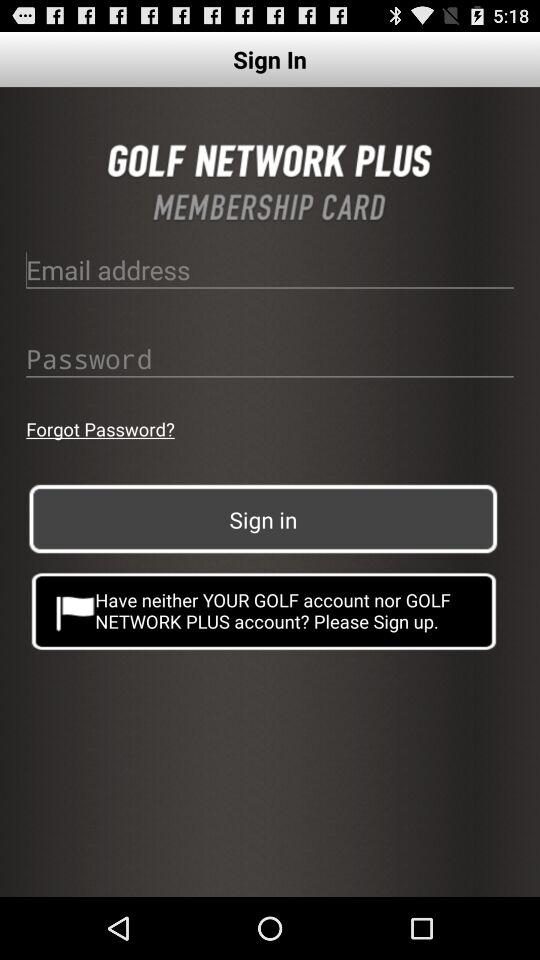What is the name of the application? The name of the application is "GOLF NETWORK PLUS". 